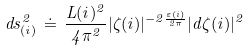Convert formula to latex. <formula><loc_0><loc_0><loc_500><loc_500>d s ^ { 2 } _ { ( i ) } \, \doteq \, \frac { L ( i ) ^ { 2 } } { 4 \pi ^ { 2 } } | \zeta ( i ) | ^ { - 2 \frac { \varepsilon ( i ) } { 2 \pi } } | d \zeta ( i ) | ^ { 2 }</formula> 